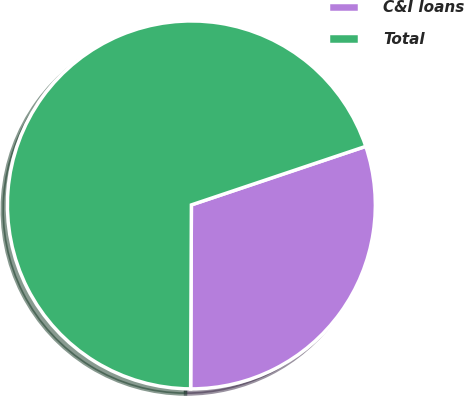Convert chart to OTSL. <chart><loc_0><loc_0><loc_500><loc_500><pie_chart><fcel>C&I loans<fcel>Total<nl><fcel>30.22%<fcel>69.78%<nl></chart> 